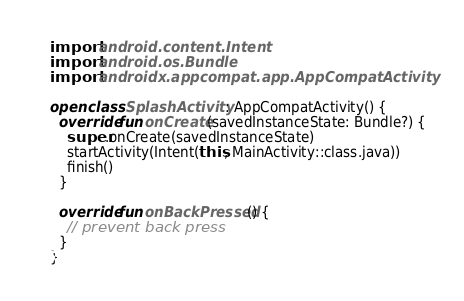<code> <loc_0><loc_0><loc_500><loc_500><_Kotlin_>import android.content.Intent
import android.os.Bundle
import androidx.appcompat.app.AppCompatActivity

open class SplashActivity : AppCompatActivity() {
  override fun onCreate(savedInstanceState: Bundle?) {
    super.onCreate(savedInstanceState)
    startActivity(Intent(this, MainActivity::class.java))
    finish()
  }

  override fun onBackPressed() {
    // prevent back press
  }
}</code> 